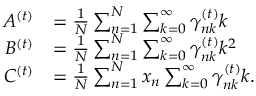<formula> <loc_0><loc_0><loc_500><loc_500>\begin{array} { r l } { A ^ { ( t ) } } & { = \frac { 1 } { N } \sum _ { n = 1 } ^ { N } \sum _ { k = 0 } ^ { \infty } \gamma _ { n k } ^ { ( t ) } k } \\ { B ^ { ( t ) } } & { = \frac { 1 } { N } \sum _ { n = 1 } ^ { N } \sum _ { k = 0 } ^ { \infty } \gamma _ { n k } ^ { ( t ) } k ^ { 2 } } \\ { C ^ { ( t ) } } & { = \frac { 1 } { N } \sum _ { n = 1 } ^ { N } x _ { n } \sum _ { k = 0 } ^ { \infty } \gamma _ { n k } ^ { ( t ) } k . } \end{array}</formula> 